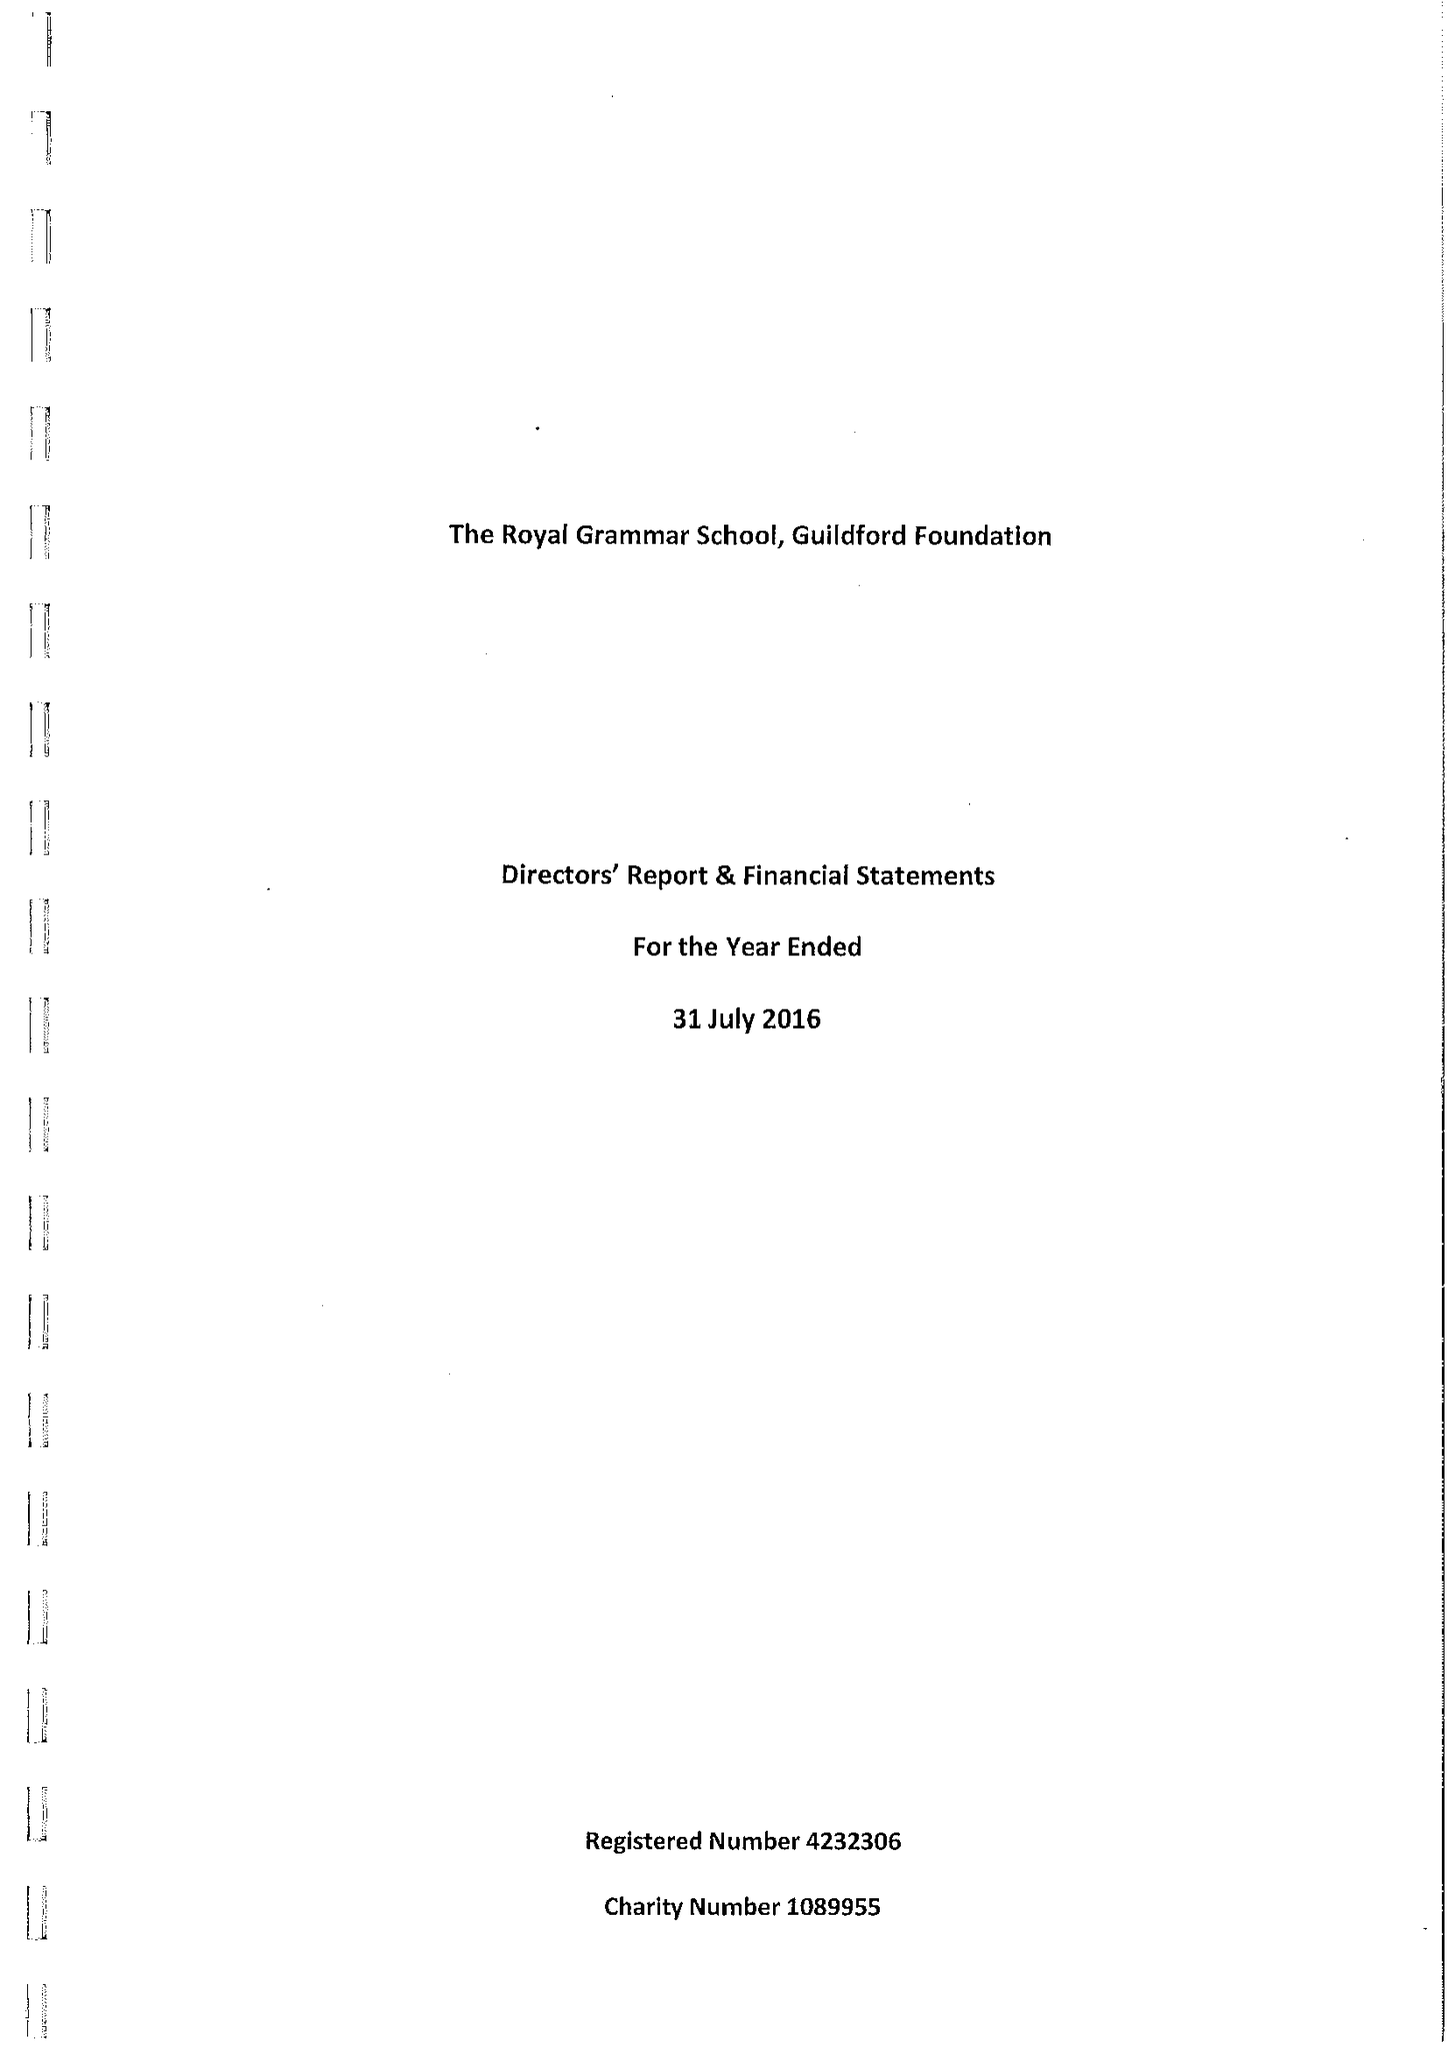What is the value for the charity_number?
Answer the question using a single word or phrase. 1089955 